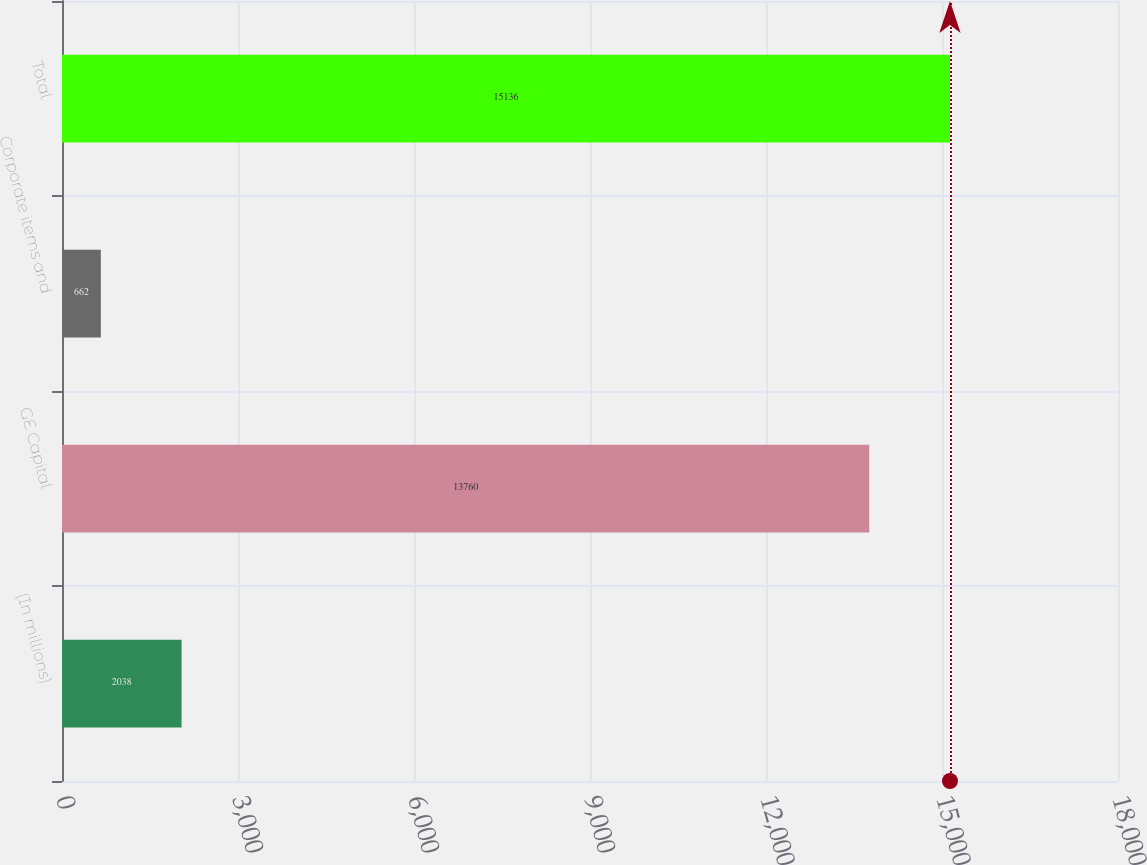<chart> <loc_0><loc_0><loc_500><loc_500><bar_chart><fcel>(In millions)<fcel>GE Capital<fcel>Corporate items and<fcel>Total<nl><fcel>2038<fcel>13760<fcel>662<fcel>15136<nl></chart> 